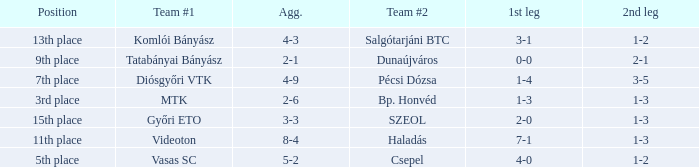What is the team #1 with an 11th place position? Videoton. 